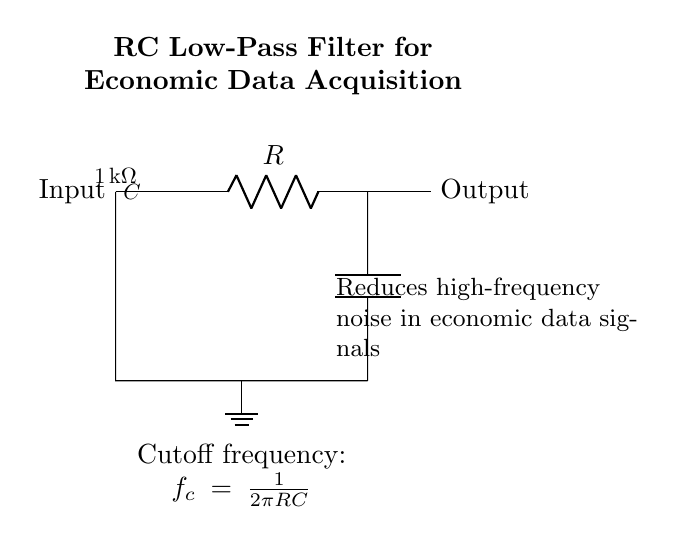What is the value of the resistor in this circuit? The value of the resistor is indicated in the circuit diagram as 1 kilohm, which is labeled on the resistor component.
Answer: 1 kilohm What is the function of the capacitor in this circuit? The capacitor in this RC filter allows low-frequency signals to pass while filtering out higher-frequency noise, as indicated by its position in the circuit.
Answer: Noise reduction What is the cutoff frequency formula shown in the diagram? The cutoff frequency formula is placed below the circuit and it describes how the cutoff frequency is determined based on resistor and capacitor values, specifically \( f_c = \frac{1}{2\pi RC} \).
Answer: 1/(2πRC) What type of filter is represented by this circuit? The circuit is a low-pass filter, as seen from its configuration, where high-frequency signals are attenuated while low-frequency signals are allowed to pass.
Answer: Low-pass filter Which component is connected to ground in the circuit? The ground connection is indicated at the bottom left of the diagram, showing that one side of the capacitor is connected to ground.
Answer: Capacitor How does the circuit reduce noise? The circuit reduces noise by utilizing a combination of a resistor and capacitor that impede high-frequency signals while allowing lower frequencies to pass through, thus filtering out the noise.
Answer: By filtering high frequencies What is the output of this circuit connected to? The output of the circuit is connected directly to the right of the resistor, indicating that the signal processed by the filter can be sent out for further analysis or usage.
Answer: Output 